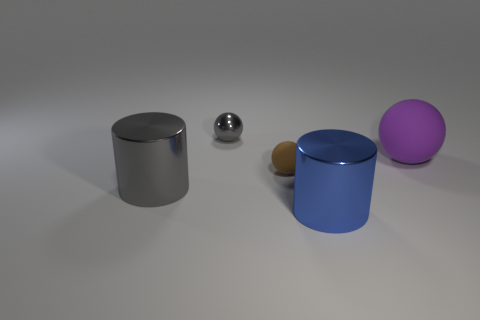Subtract all rubber spheres. How many spheres are left? 1 Add 4 big cylinders. How many objects exist? 9 Subtract all cyan spheres. Subtract all blue cylinders. How many spheres are left? 3 Subtract 0 red balls. How many objects are left? 5 Subtract all balls. How many objects are left? 2 Subtract all small gray metallic things. Subtract all blue metallic cylinders. How many objects are left? 3 Add 4 small balls. How many small balls are left? 6 Add 1 tiny gray objects. How many tiny gray objects exist? 2 